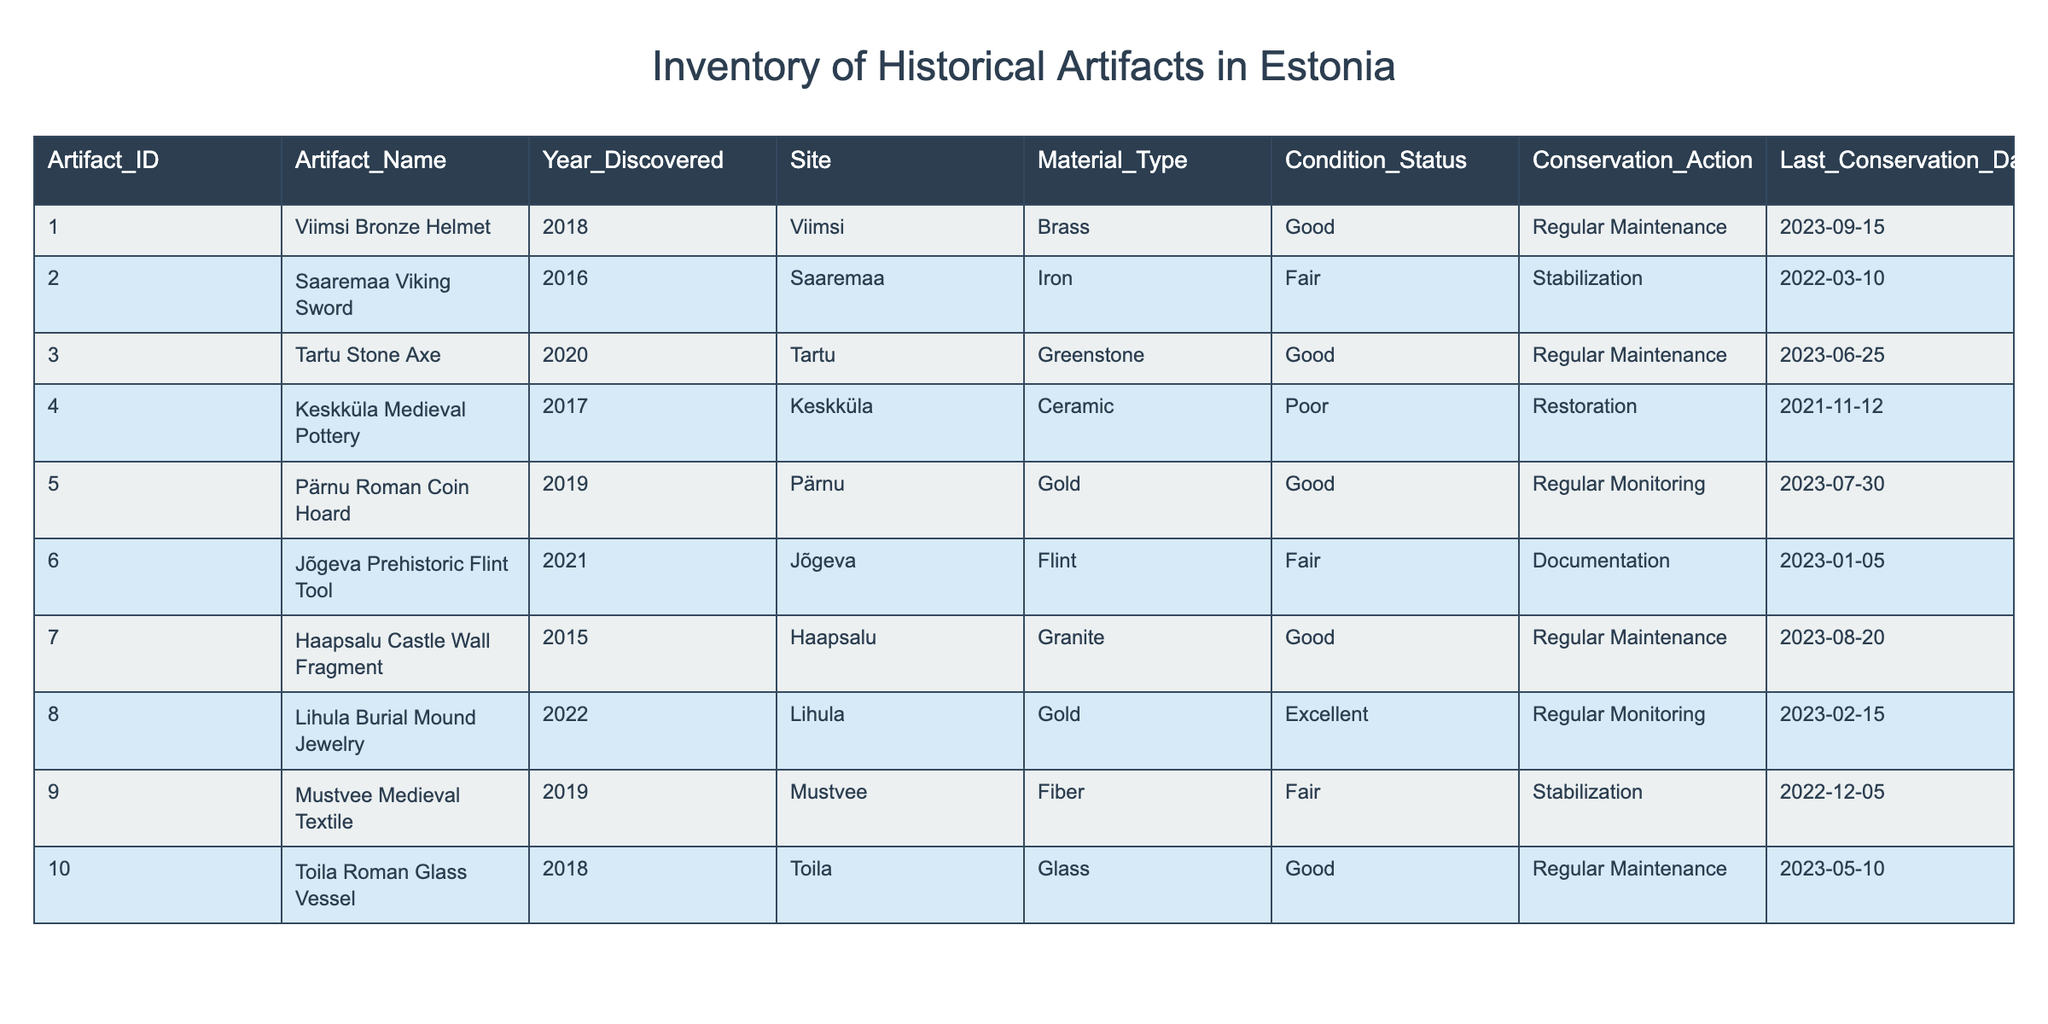What is the Condition Status of the Tartu Stone Axe? The Tartu Stone Axe appears in the table under the 'Artifact_Name' column, where its corresponding 'Condition_Status' is listed. It shows that the condition status is 'Good'.
Answer: Good Which artifact was last conserved on September 15, 2023? In the table, we look at the 'Last_Conservation_Date' column for each artifact. The date September 15, 2023, corresponds to the 'Viimsi Bronze Helmet', indicating it was the last to be conserved on that date.
Answer: Viimsi Bronze Helmet How many artifacts are in 'Fair' condition? The artifacts with 'Fair' condition status are the 'Saaremaa Viking Sword,' 'Jõgeva Prehistoric Flint Tool,' and 'Mustvee Medieval Textile.' We can count the entries for 'Fair' condition: there are 3 artifacts.
Answer: 3 Is the Haapsalu Castle Wall Fragment in excellent condition? We can refer to the 'Condition_Status' column for the 'Haapsalu Castle Wall Fragment.' The status is listed as 'Good', which means it is not in excellent condition.
Answer: No Which conservation action is most common among the artifacts? To determine the most common conservation action, we analyze the 'Conservation_Action' column. Here, we have 'Regular Maintenance' (4 instances), 'Stabilization' (3), 'Restoration' (1), and 'Documentation' (1). Regular Maintenance is the most frequent action.
Answer: Regular Maintenance Is the Lihula Burial Mound Jewelry older than the Pärnu Roman Coin Hoard? Looking at the 'Year_Discovered' column, the Lihula Burial Mound Jewelry was discovered in 2022, while the Pärnu Roman Coin Hoard was uncovered in 2019. Since 2022 is later than 2019, Lihula is not older.
Answer: No What is the average age of the artifacts in the table? We can calculate the average age by subtracting the year discovered from the current year (2023). The ages are: 5 (2018), 7 (2016), 3 (2020), 6 (2017), 4 (2019), 2 (2021), 1 (2022), 8 (2015), 1 (2019), and 5 (2018). The sum of ages is 42 and dividing by the number of artifacts (10), we get an average age of 4.2.
Answer: 4.2 Are there any artifacts made of ceramic? By scanning through the 'Material_Type' column, we find one artifact made of ceramic, which is 'Keskküla Medieval Pottery.' Therefore, yes, there is an artifact made of ceramic.
Answer: Yes 